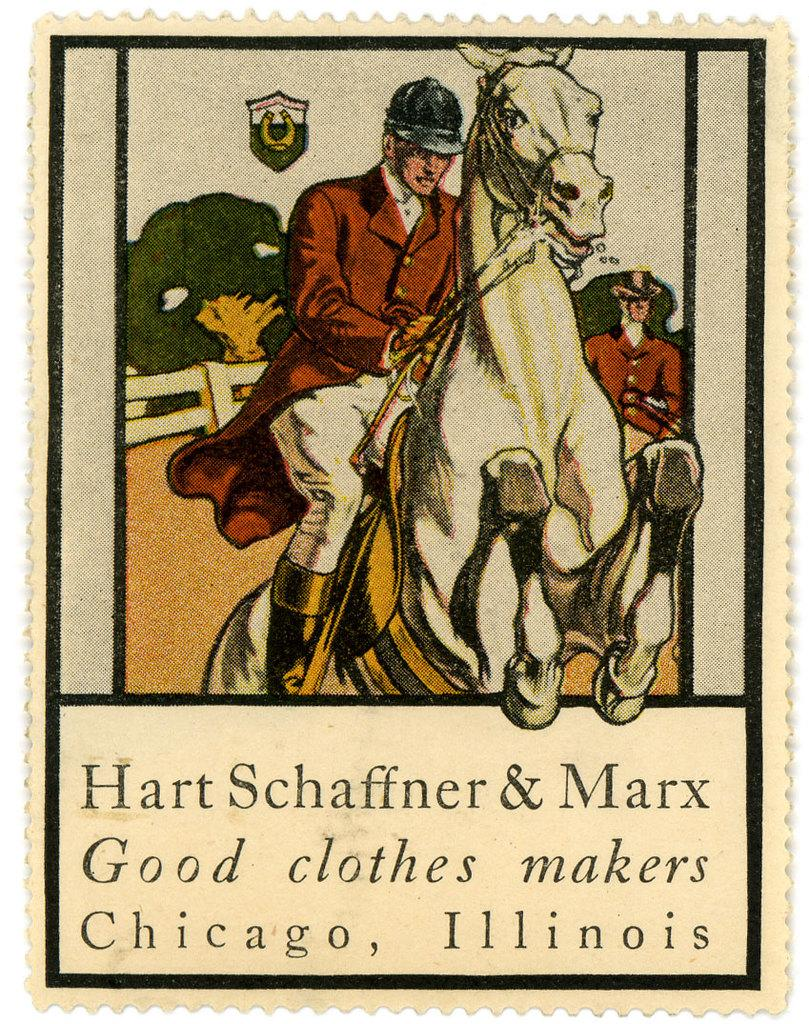What is the main subject of the stamp in the picture? The stamp contains a photo of a person riding a horse. Are there any other people in the photo? Yes, there is another person in the photo. What can be seen in the background of the photo? There is a fence, trees, and the sky visible in the photo. What additional features can be found on the stamp? There is a symbol and words on the stamp. What type of soup is being served to the girls in the image? There are no girls or soup present in the image; it features a stamp with a photo of a person riding a horse. 